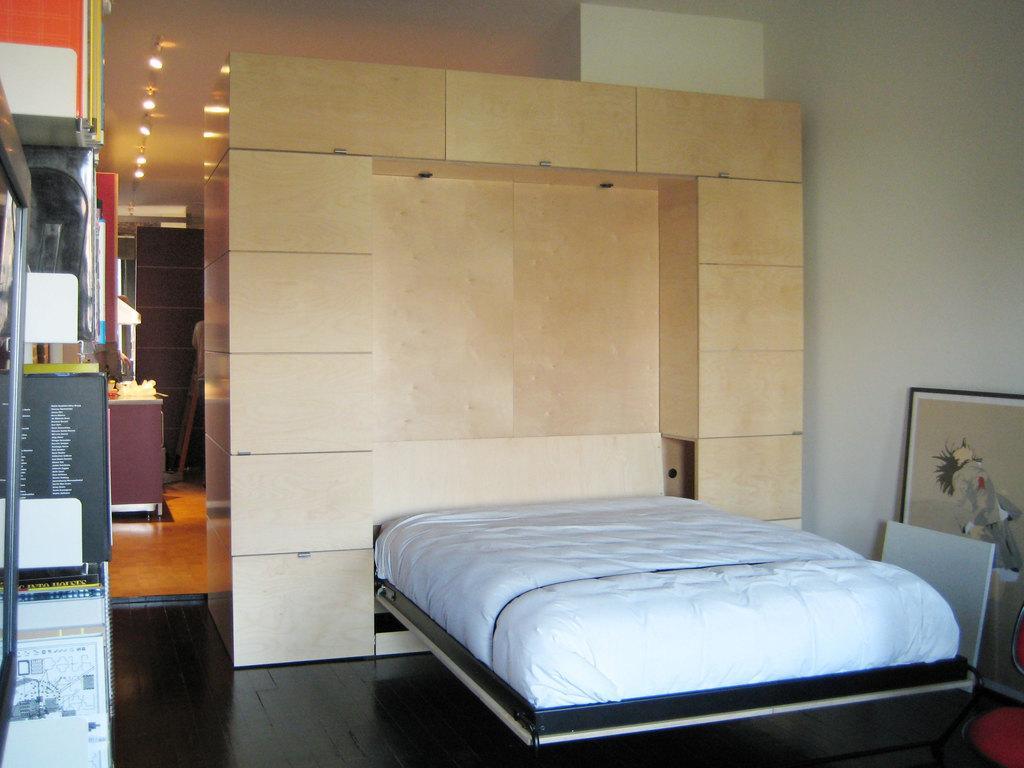How would you summarize this image in a sentence or two? In this image I can see on the right side there is a bed in white color and there is a photo frame, on the left side there are ceiling lights at the top. 